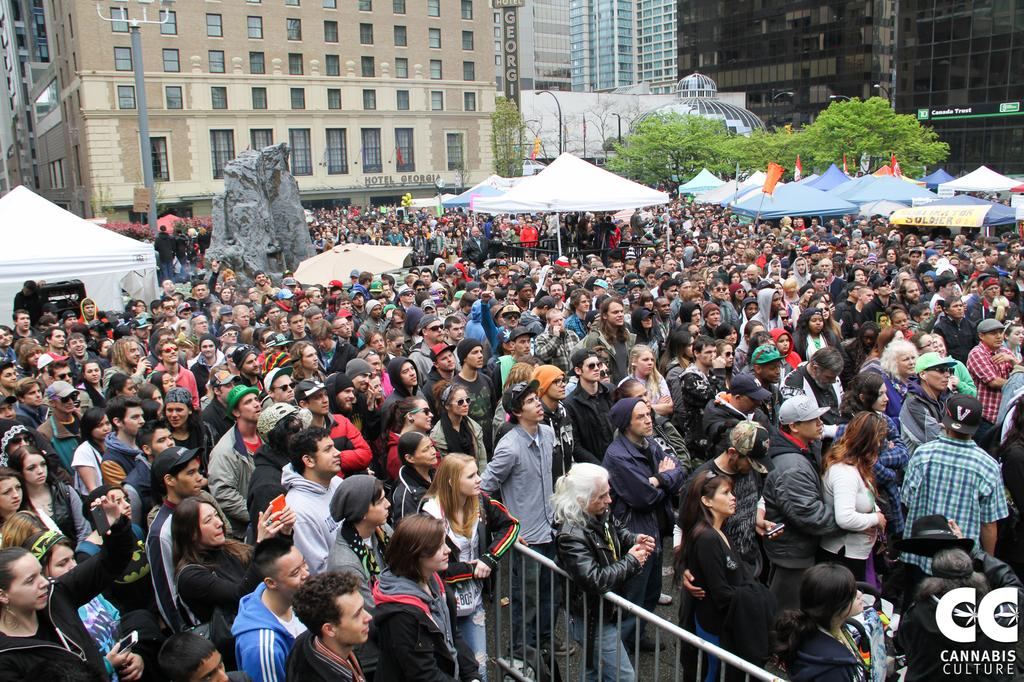What is the main subject of the image? The main subject of the image is a crowd. What objects are being used by the people in the crowd? Umbrellas are being used by the people in the crowd. What decorative or symbolic items can be seen in the image? Flags are present in the image. What type of natural elements are visible in the image? Trees are visible in the image. What structures are present in the image? Poles and a fence are present in the image. What man-made objects are visible in the image? Boards are present in the image. What can be seen in the background of the image? Buildings are visible in the background of the image. What type of record is being played in the image? There is no record player or music being played in the image. How many hands are visible in the image? There is no specific mention of hands in the image, so it is impossible to determine how many hands are visible. 